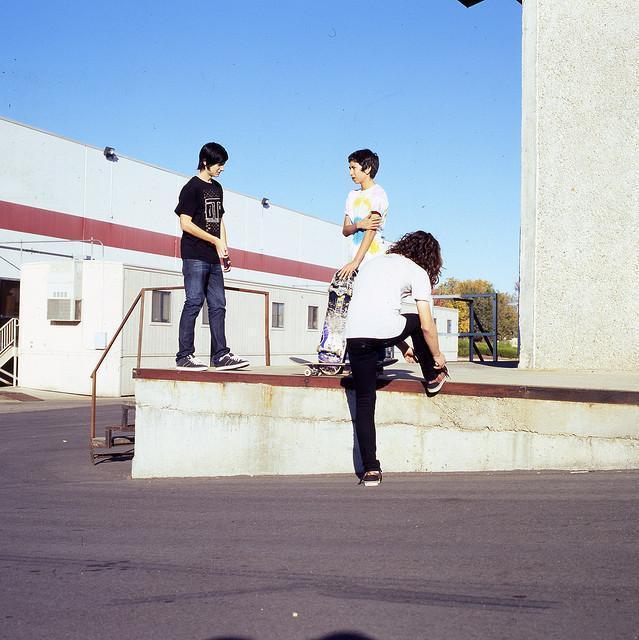Why is the long haired boy touching his shoe?
Select the accurate answer and provide justification: `Answer: choice
Rationale: srationale.`
Options: Scratching itch, tying laces, undressing, stretching. Answer: tying laces.
Rationale: The long haired boy is touching his shoe, attempting to tie his laces. 